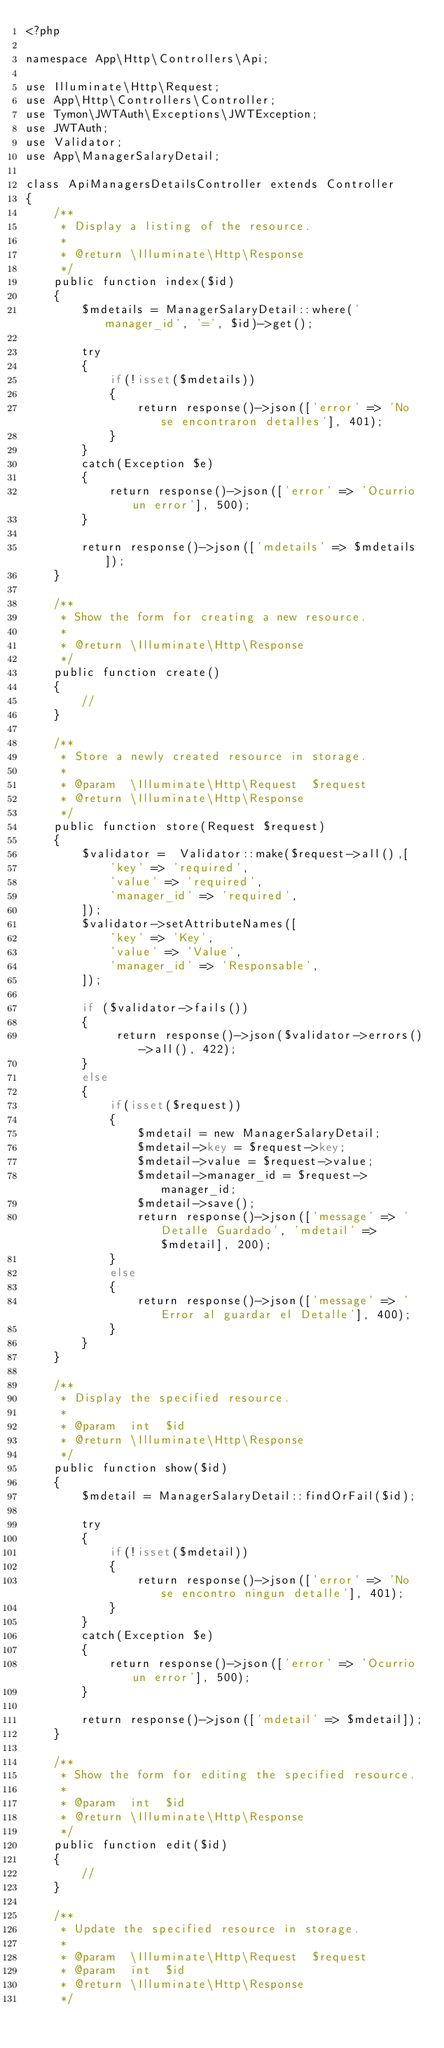<code> <loc_0><loc_0><loc_500><loc_500><_PHP_><?php

namespace App\Http\Controllers\Api;

use Illuminate\Http\Request;
use App\Http\Controllers\Controller;
use Tymon\JWTAuth\Exceptions\JWTException;
use JWTAuth;
use Validator;
use App\ManagerSalaryDetail;

class ApiManagersDetailsController extends Controller
{
    /**
     * Display a listing of the resource.
     *
     * @return \Illuminate\Http\Response
     */
    public function index($id)
    {
        $mdetails = ManagerSalaryDetail::where('manager_id', '=', $id)->get();

        try
        {
            if(!isset($mdetails))
            {
                return response()->json(['error' => 'No se encontraron detalles'], 401);
            }
        }
        catch(Exception $e)
        {
            return response()->json(['error' => 'Ocurrio un error'], 500);
        }

        return response()->json(['mdetails' => $mdetails]);
    }

    /**
     * Show the form for creating a new resource.
     *
     * @return \Illuminate\Http\Response
     */
    public function create()
    {
        //
    }

    /**
     * Store a newly created resource in storage.
     *
     * @param  \Illuminate\Http\Request  $request
     * @return \Illuminate\Http\Response
     */
    public function store(Request $request)
    {
        $validator =  Validator::make($request->all(),[ 
            'key' => 'required',
            'value' => 'required',
            'manager_id' => 'required',
        ]);
        $validator->setAttributeNames([
            'key' => 'Key',
            'value' => 'Value',
            'manager_id' => 'Responsable',
        ]);
       
        if ($validator->fails()) 
        {
             return response()->json($validator->errors()->all(), 422);
        }
        else
        {
            if(isset($request))
            {
                $mdetail = new ManagerSalaryDetail;
                $mdetail->key = $request->key;
                $mdetail->value = $request->value;
                $mdetail->manager_id = $request->manager_id;
                $mdetail->save();
                return response()->json(['message' => 'Detalle Guardado', 'mdetail' => $mdetail], 200);
            }
            else
            {
                return response()->json(['message' => 'Error al guardar el Detalle'], 400);
            }
        }
    }

    /**
     * Display the specified resource.
     *
     * @param  int  $id
     * @return \Illuminate\Http\Response
     */
    public function show($id)
    {
        $mdetail = ManagerSalaryDetail::findOrFail($id);

        try
        {
            if(!isset($mdetail))
            {
                return response()->json(['error' => 'No se encontro ningun detalle'], 401);
            }
        }
        catch(Exception $e)
        {
            return response()->json(['error' => 'Ocurrio un error'], 500);
        }

        return response()->json(['mdetail' => $mdetail]);
    }

    /**
     * Show the form for editing the specified resource.
     *
     * @param  int  $id
     * @return \Illuminate\Http\Response
     */
    public function edit($id)
    {
        //
    }

    /**
     * Update the specified resource in storage.
     *
     * @param  \Illuminate\Http\Request  $request
     * @param  int  $id
     * @return \Illuminate\Http\Response
     */</code> 